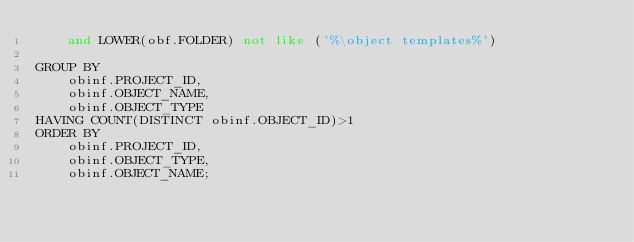<code> <loc_0><loc_0><loc_500><loc_500><_SQL_>    and LOWER(obf.FOLDER) not like ('%\object templates%')

GROUP BY 
    obinf.PROJECT_ID, 
    obinf.OBJECT_NAME, 
    obinf.OBJECT_TYPE
HAVING COUNT(DISTINCT obinf.OBJECT_ID)>1
ORDER BY 
    obinf.PROJECT_ID,
    obinf.OBJECT_TYPE,
    obinf.OBJECT_NAME;
</code> 